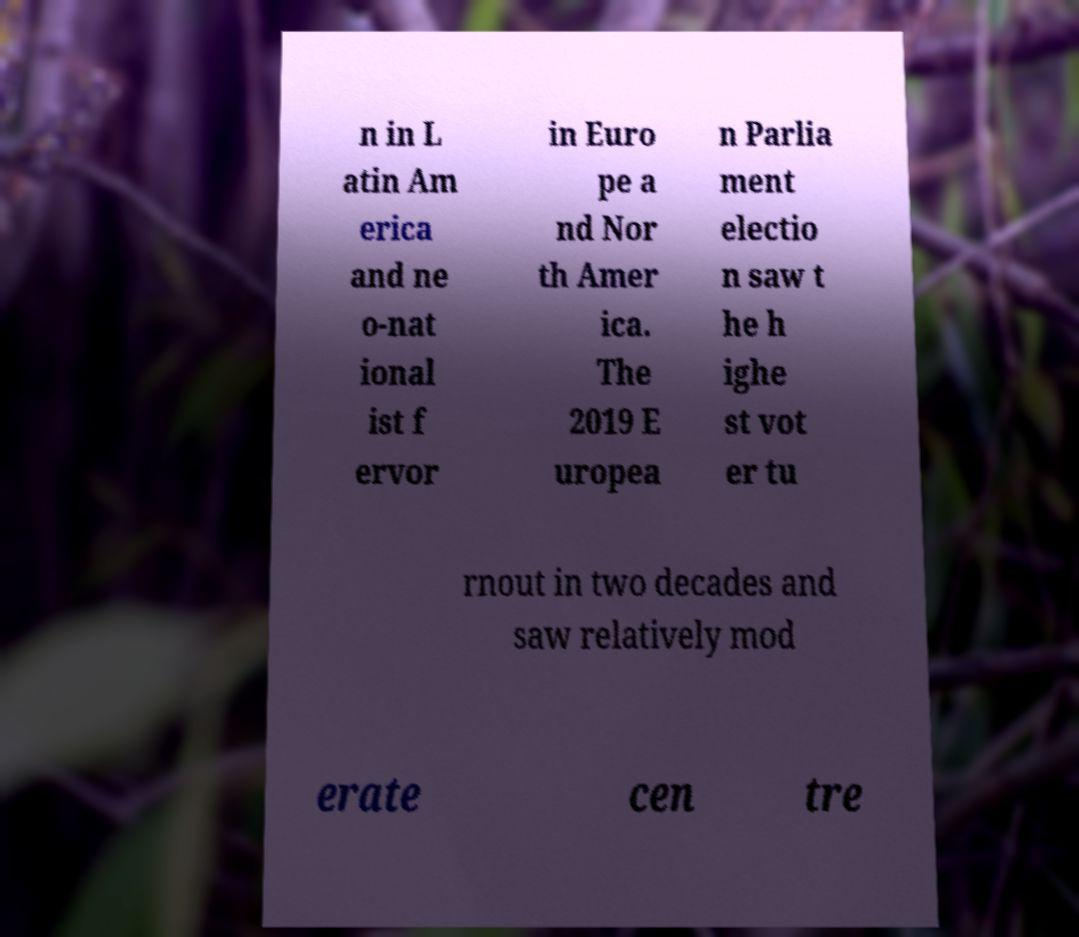Please identify and transcribe the text found in this image. n in L atin Am erica and ne o-nat ional ist f ervor in Euro pe a nd Nor th Amer ica. The 2019 E uropea n Parlia ment electio n saw t he h ighe st vot er tu rnout in two decades and saw relatively mod erate cen tre 